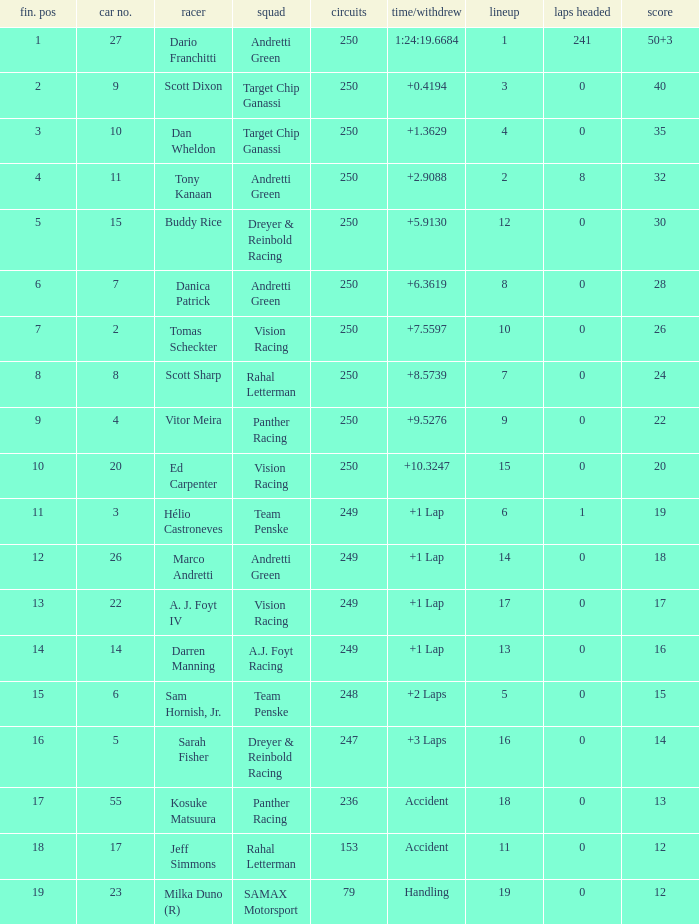Identify the total count of fin positions for 12 accident points. 1.0. 